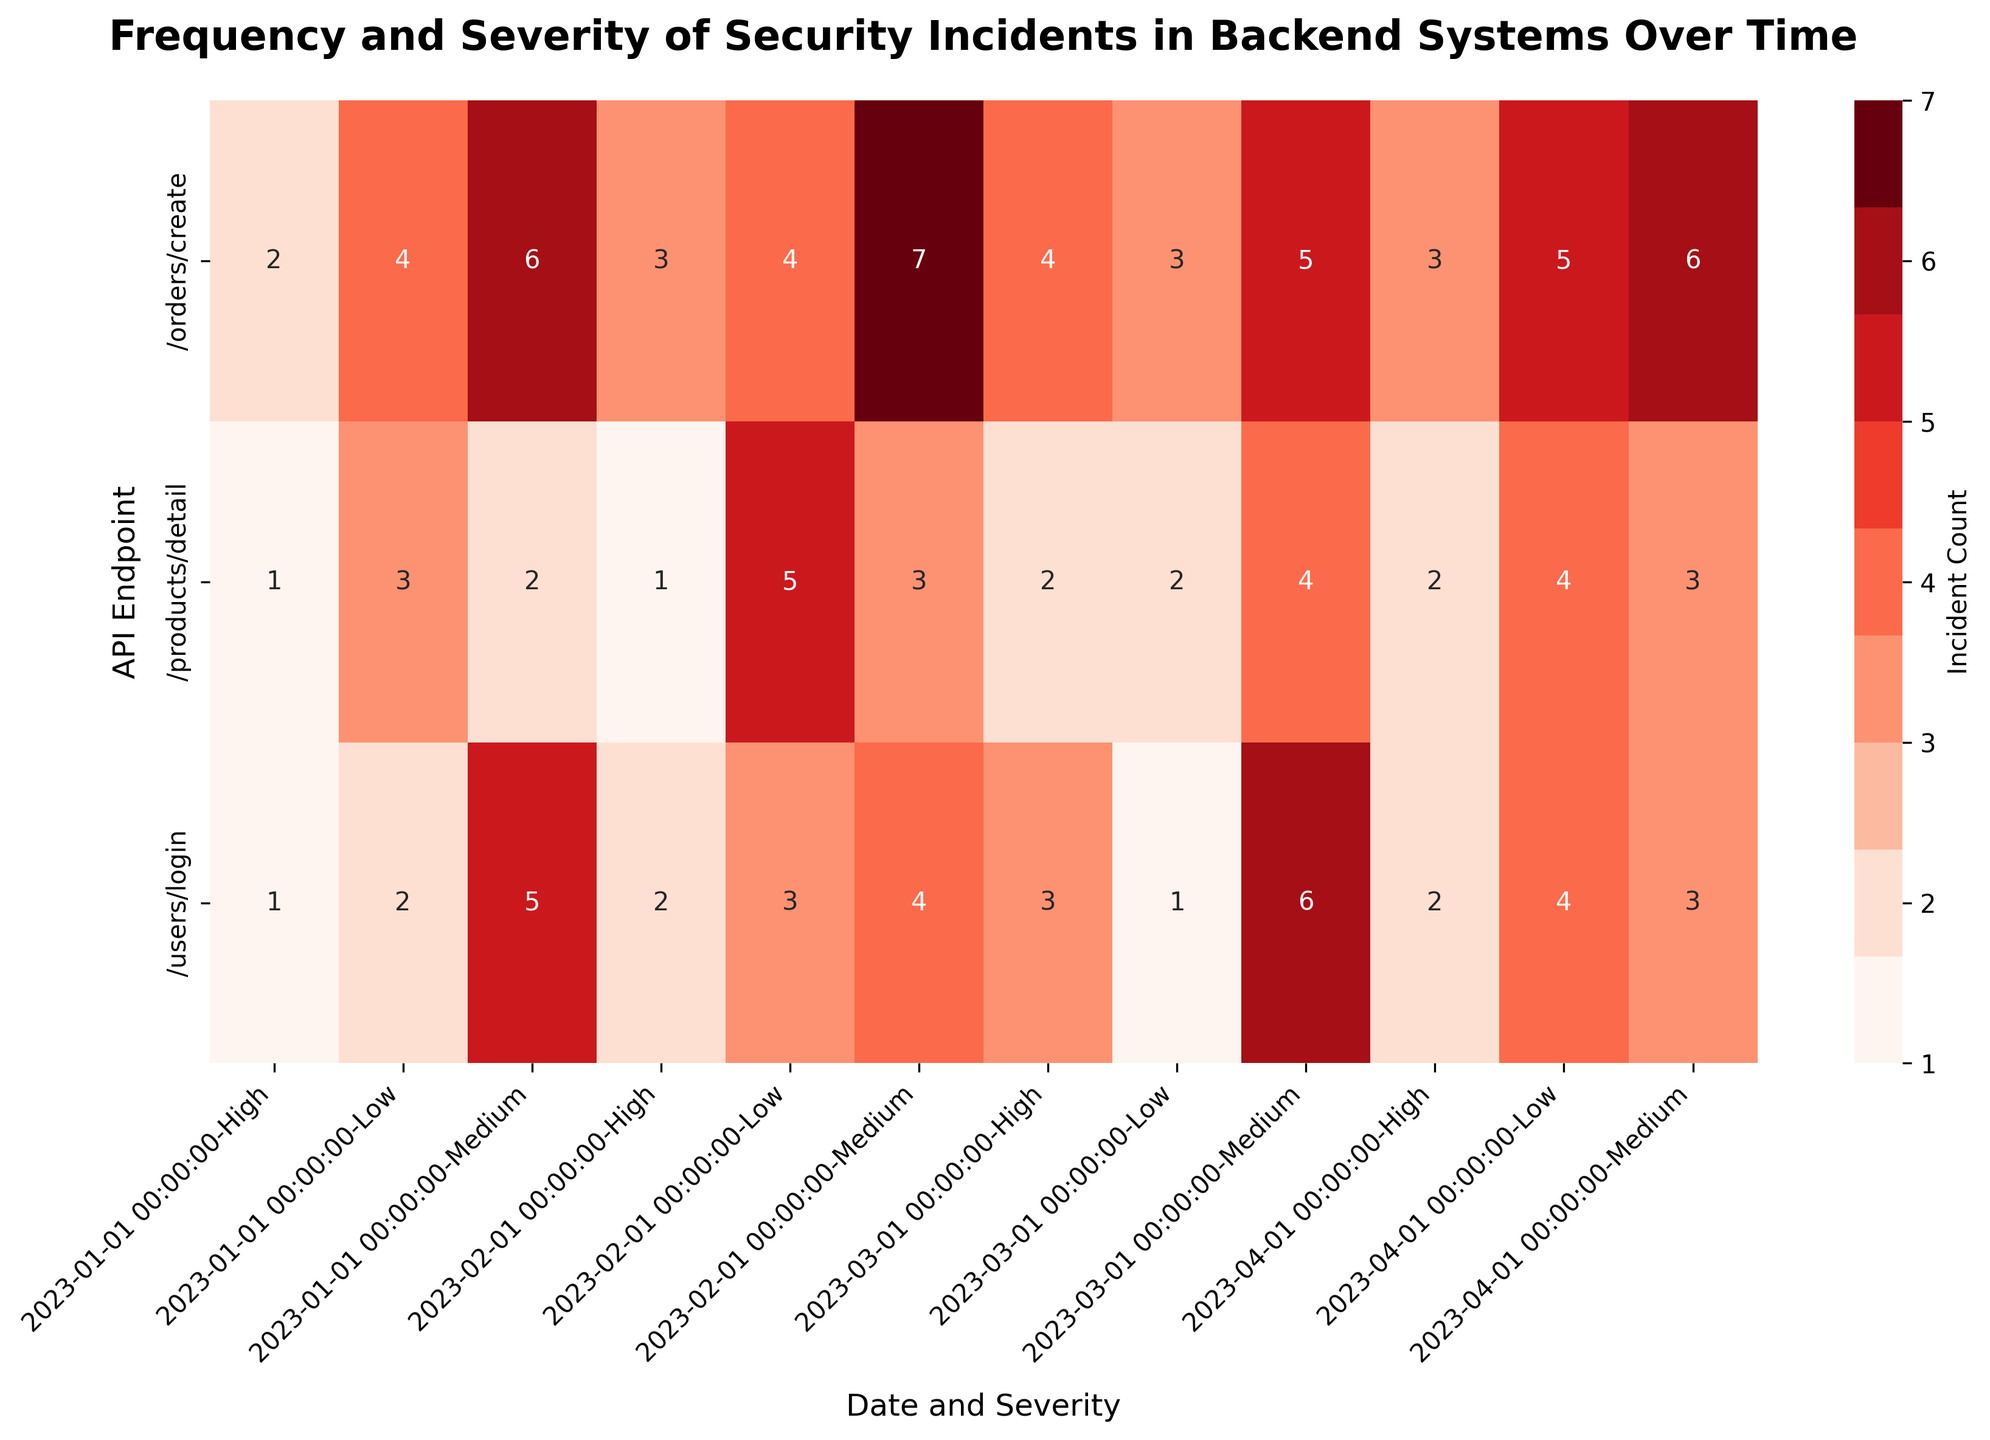What's the title of the heatmap? The title is typically displayed at the top of the figure, usually in larger or bold font to make it noticeable. In this case, the title is "Frequency and Severity of Security Incidents in Backend Systems Over Time."
Answer: Frequency and Severity of Security Incidents in Backend Systems Over Time Which API endpoint had the highest number of high-severity incidents in January 2023? Look across the 'High' severity row under January 2023 columns for each API endpoint and find the highest count. For January, /orders/create has 2 high-severity incidents, which is the highest.
Answer: /orders/create What's the total count of security incidents for /users/login in February 2023 across all severity levels? Add up the counts of 'Low', 'Medium', and 'High' severity incidents for /users/login in February 2023: 3 (Low) + 4 (Medium) + 2 (High) = 9.
Answer: 9 Which month had the highest total incidents for /products/detail? Calculate the total incident count per month for /products/detail by summing counts for 'Low', 'Medium', and 'High' severity levels. Compare the sums for each month. February has the highest: 5 (Low) + 3 (Medium) + 1 (High) = 9.
Answer: February 2023 How does the number of medium-severity incidents for /orders/create in March compare to those in April? Look at the 'Medium' severity counts for /orders/create in March and April: March has 5 incidents, and April has 6 incidents. April has 1 more incident than March.
Answer: April has 1 more incident than March What is the most frequent severity level of incidents for /products/detail in all months combined? Sum the counts for each severity level ('Low', 'Medium', 'High') across all months for /products/detail. Low: 3+5+2+4=14; Medium: 2+3+4+3=12; High: 1+1+2+2=6. 'Low' is the most frequent with a total of 14.
Answer: Low Which API endpoint had no high-severity incidents in April 2023? Examine the 'High' severity count for each API endpoint in April 2023. /products/detail and /users/login have high-severity incidents, but /orders/create has no incidents with High severity. The correct endpoint is /products/detail.
Answer: /products/detail On which date did /users/login have the highest number of medium-severity incidents? Compare the counts for 'Medium' severity incidents for /users/login across all dates. The highest count is 6 incidents, occurring in March 2023.
Answer: March 2023 What’s the trend change in the total number of incidents for /orders/create from January to April 2023? Calculate the total incidents for /orders/create each month: January: 4(L) + 6(M) + 2(H) = 12; February: 4+7+3 = 14; March: 3+5+4 = 12; April: 5+6+3 = 14. Identify the trend changes from month to month. The numbers roughly fluctuate around 12-14, showing a slight increase in February and April.
Answer: Fluctuating with a slight increase in February and April 